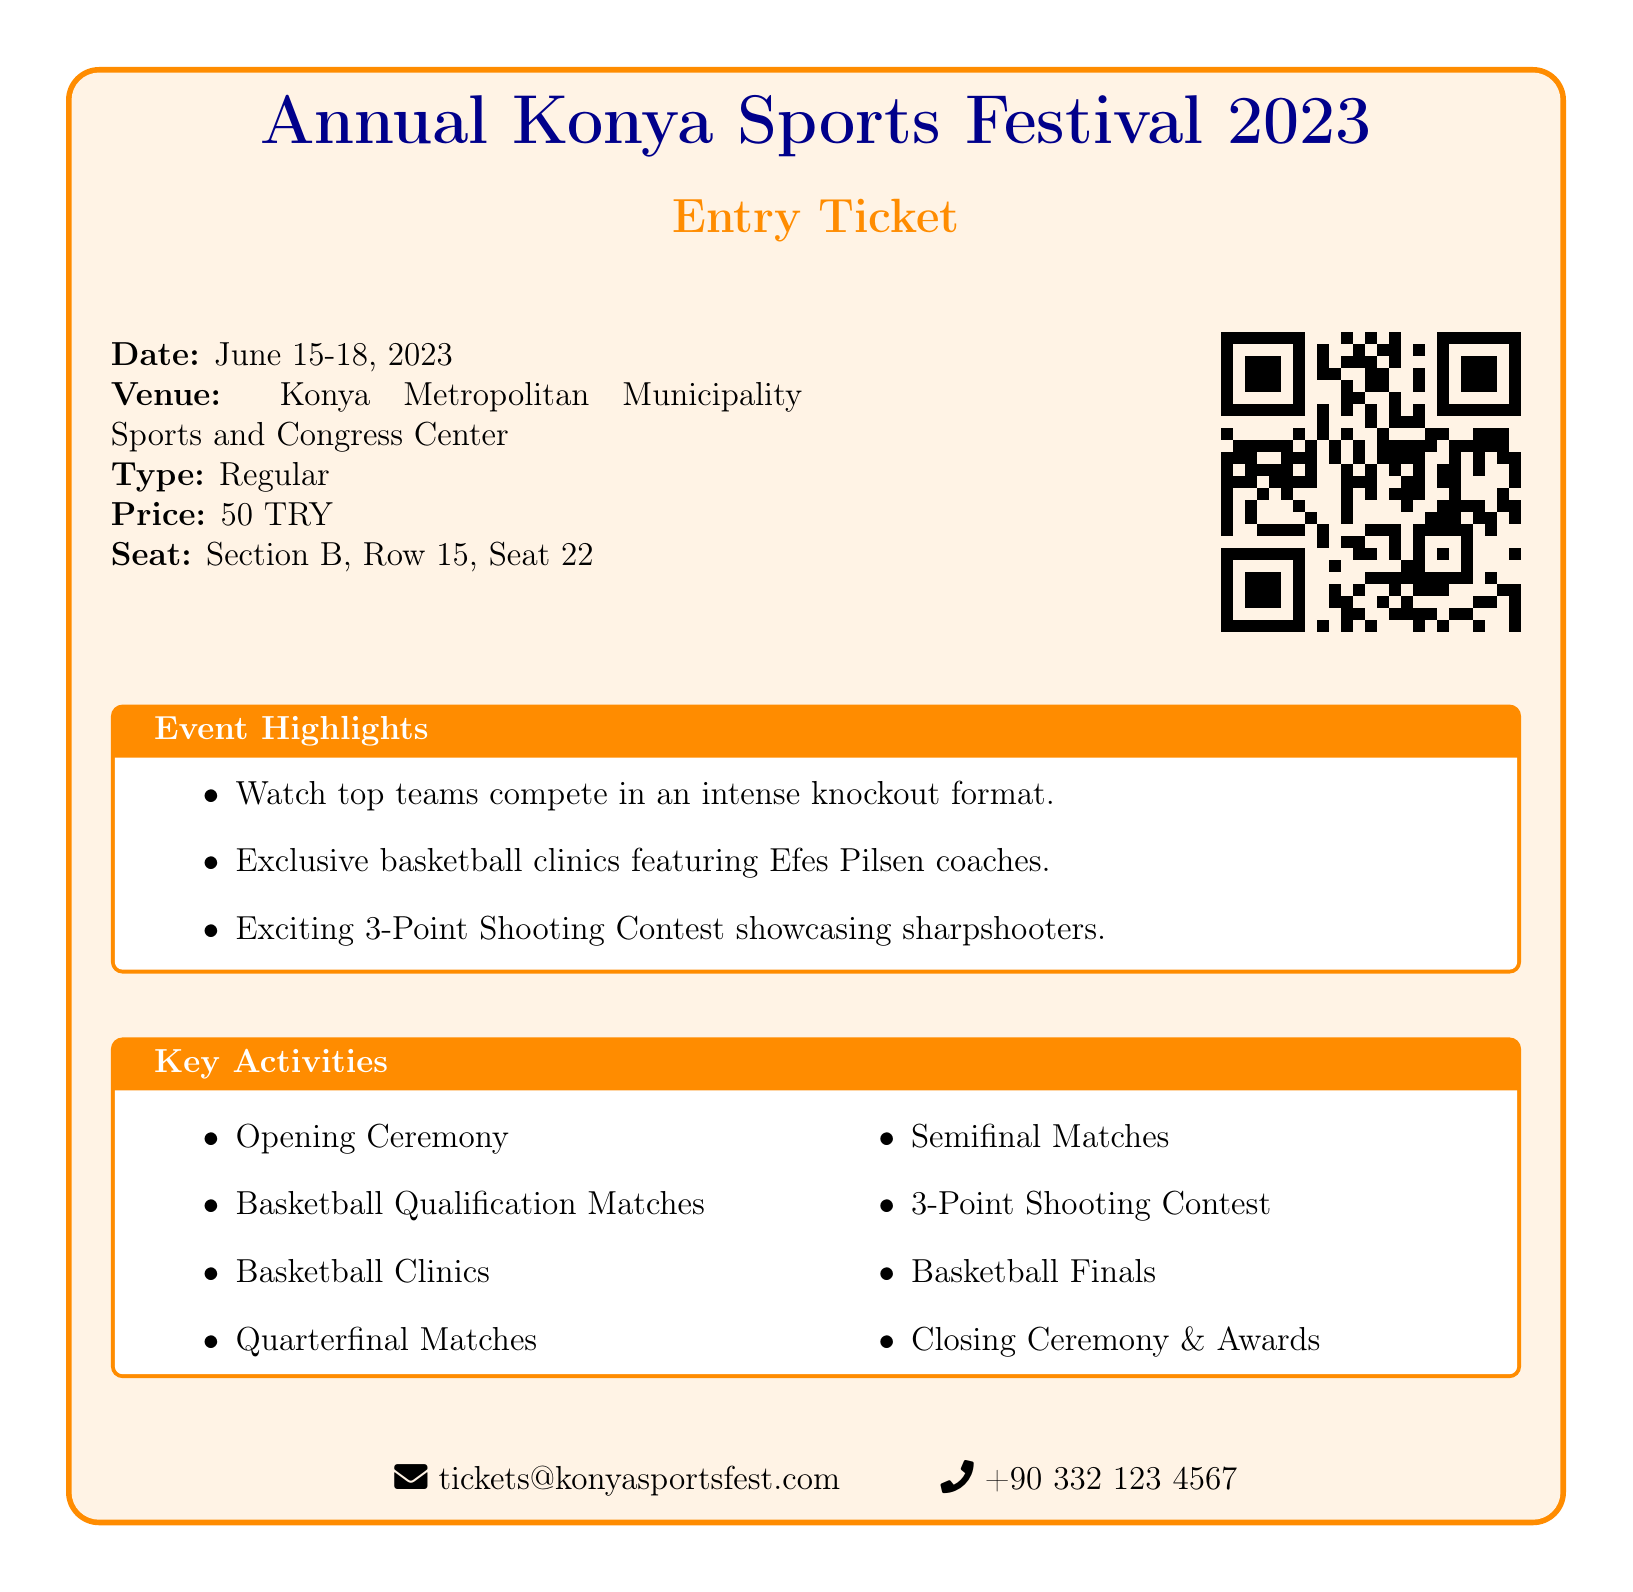What are the event dates? The event dates are explicitly stated in the document.
Answer: June 15-18, 2023 What is the ticket price? The ticket price is mentioned clearly in the document.
Answer: 50 TRY What venue is hosting the event? The venue information is provided in the ticket details.
Answer: Konya Metropolitan Municipality Sports and Congress Center Which team's coaches are featured in the basketball clinics? The document specifies the team's coaches associated with the clinics.
Answer: Efes Pilsen What type of matches will take place? The document lists the types of matches included in the schedule.
Answer: Qualification Matches, Quarterfinal Matches, Semifinal Matches, Finals What special activity highlights are included? The document highlights key activities available during the event.
Answer: 3-Point Shooting Contest How many seats are in Section B, Row 15? The document provides specific seat details for the ticket holder.
Answer: Seat 22 What is the email contact for the event? The email contact is clearly stated at the bottom of the document.
Answer: tickets@konyasportsfest.com 